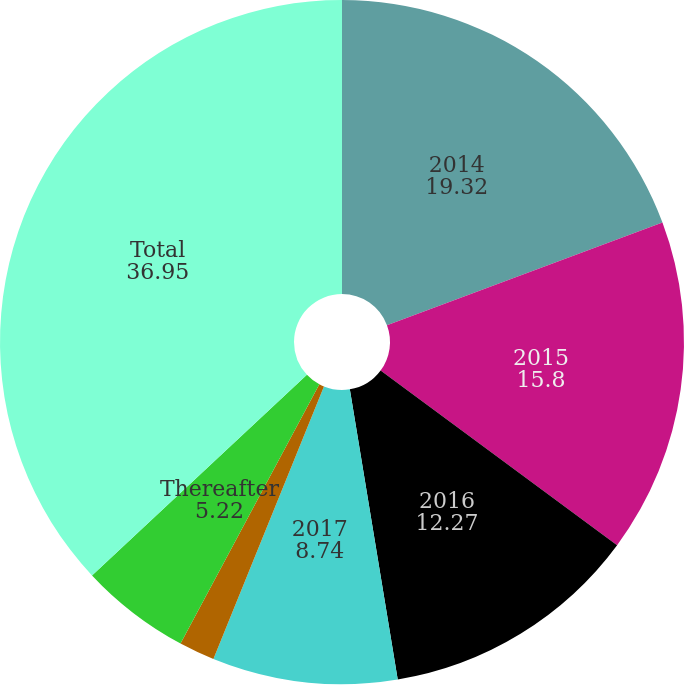<chart> <loc_0><loc_0><loc_500><loc_500><pie_chart><fcel>2014<fcel>2015<fcel>2016<fcel>2017<fcel>2018<fcel>Thereafter<fcel>Total<nl><fcel>19.32%<fcel>15.8%<fcel>12.27%<fcel>8.74%<fcel>1.69%<fcel>5.22%<fcel>36.95%<nl></chart> 